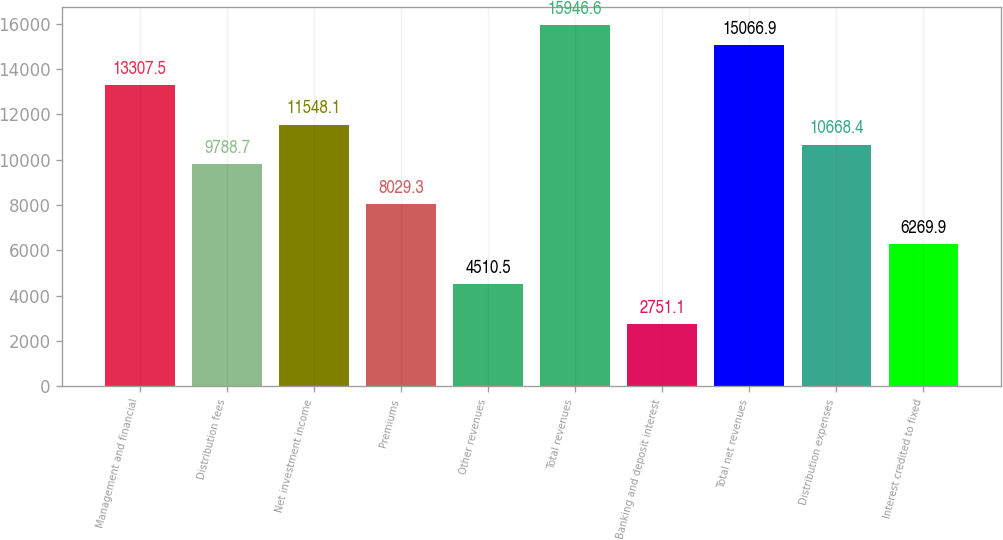Convert chart. <chart><loc_0><loc_0><loc_500><loc_500><bar_chart><fcel>Management and financial<fcel>Distribution fees<fcel>Net investment income<fcel>Premiums<fcel>Other revenues<fcel>Total revenues<fcel>Banking and deposit interest<fcel>Total net revenues<fcel>Distribution expenses<fcel>Interest credited to fixed<nl><fcel>13307.5<fcel>9788.7<fcel>11548.1<fcel>8029.3<fcel>4510.5<fcel>15946.6<fcel>2751.1<fcel>15066.9<fcel>10668.4<fcel>6269.9<nl></chart> 